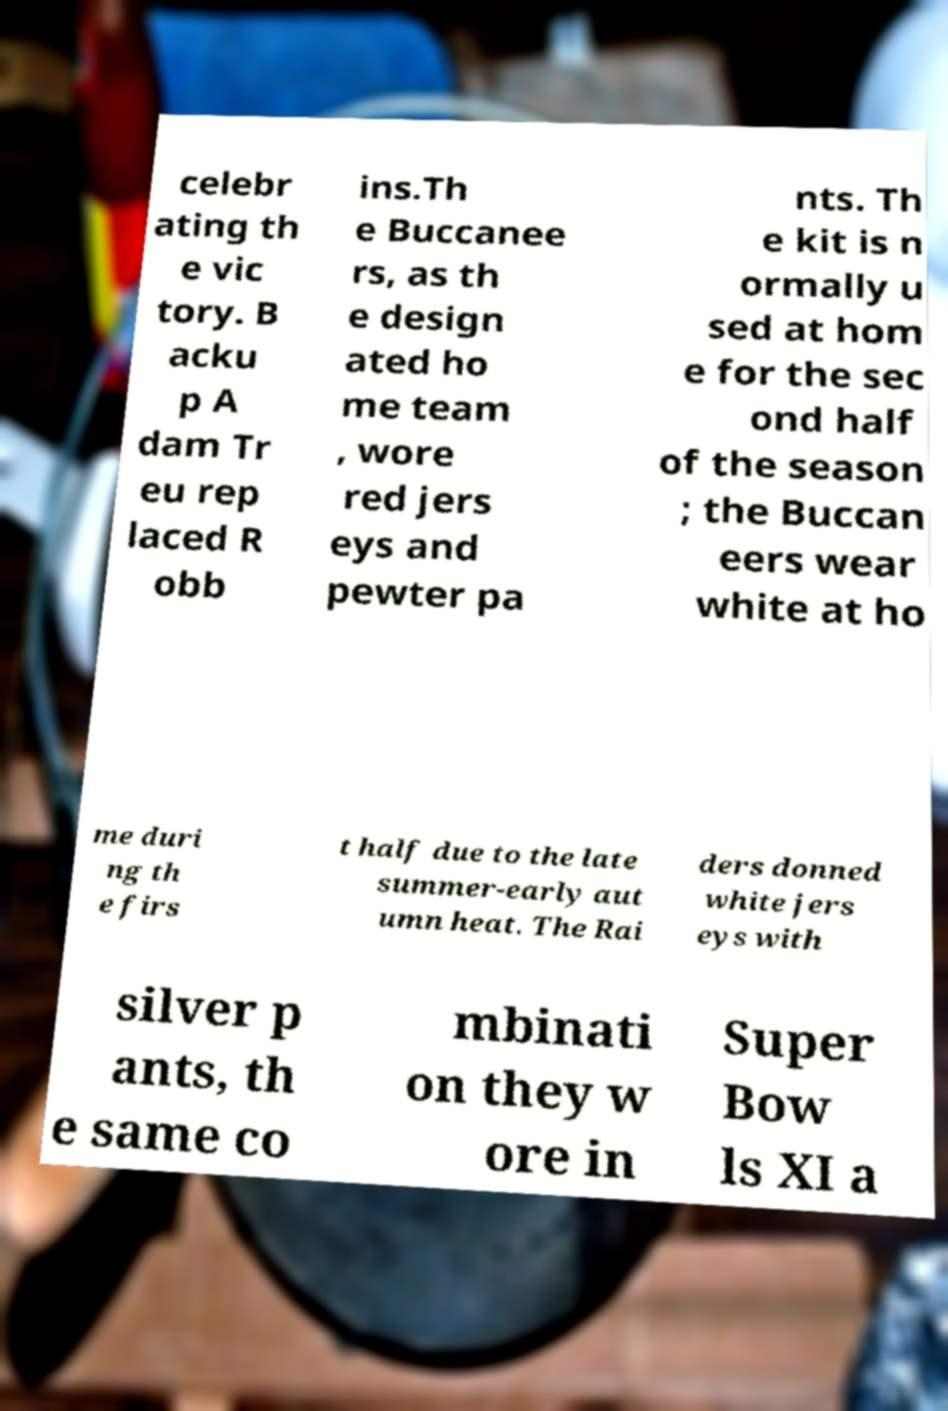There's text embedded in this image that I need extracted. Can you transcribe it verbatim? celebr ating th e vic tory. B acku p A dam Tr eu rep laced R obb ins.Th e Buccanee rs, as th e design ated ho me team , wore red jers eys and pewter pa nts. Th e kit is n ormally u sed at hom e for the sec ond half of the season ; the Buccan eers wear white at ho me duri ng th e firs t half due to the late summer-early aut umn heat. The Rai ders donned white jers eys with silver p ants, th e same co mbinati on they w ore in Super Bow ls XI a 